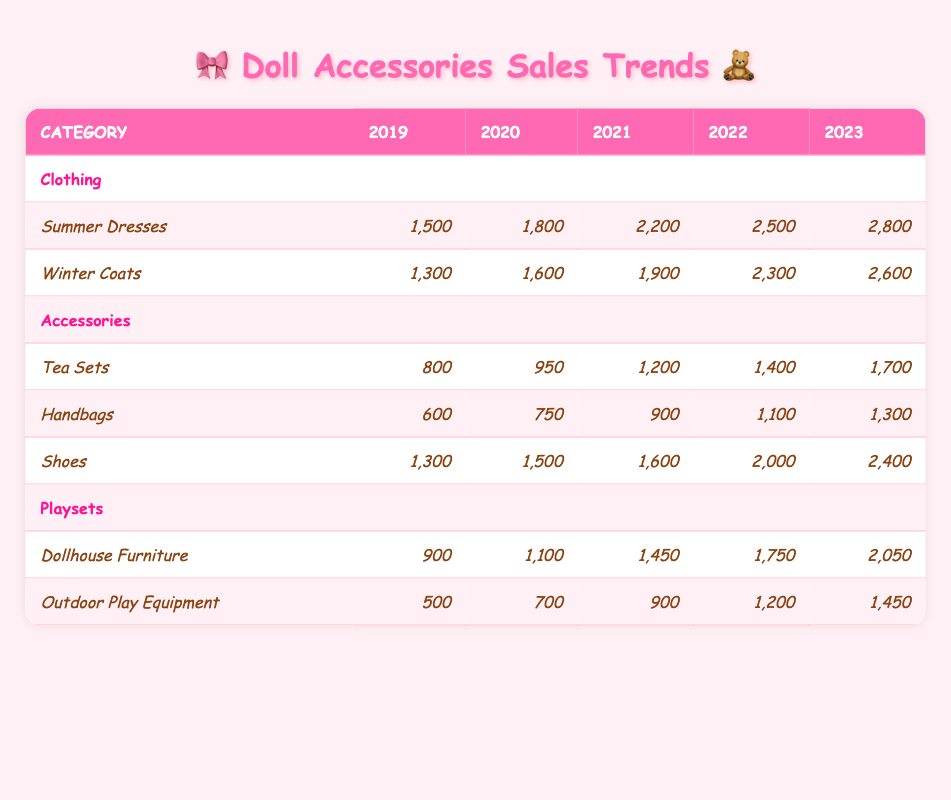What were the sales of Summer Dresses in 2021? According to the table, the sales of Summer Dresses in 2021 are listed as 2,200.
Answer: 2,200 Which category had the highest total sales in 2023? To find the highest total sales, we need to add the sales for each category in 2023: Clothing (2,800) + Accessories (1,700 + 1,300 + 2,400) + Playsets (2,050 + 1,450) = 2,800 + 5,400 + 3,500 = 11,700. Therefore, the category with the highest total is Clothing.
Answer: Clothing Did the sales of Tea Sets increase every year? The sales figures for Tea Sets are: 800 (2019), 950 (2020), 1200 (2021), 1400 (2022), and 1700 (2023). Since all values show an increase year over year, the answer is yes.
Answer: Yes What is the average sales of Shoes over the five years? To find the average sales of Shoes, we sum the sales from 2019 to 2023: 1,300 + 1,500 + 1,600 + 2,000 + 2,400 = 10,800. Then, we divide this sum by the five years: 10,800 / 5 = 2,160.
Answer: 2,160 Which had higher sales in 2022, Winter Coats or Dollhouse Furniture? The sales for Winter Coats in 2022 is 2,300 and for Dollhouse Furniture is 1,750. Since 2,300 is greater than 1,750, Winter Coats had higher sales in 2022.
Answer: Winter Coats How much did the sales of Handbags grow from 2019 to 2023? The sales of Handbags in 2019 were 600 and in 2023 it was 1,300. To find the growth, subtract the earlier value from the later value: 1,300 - 600 = 700. Thus, Handbags sales grew by 700 from 2019 to 2023.
Answer: 700 Which accessory category showed the least sales in 2020? In 2020, the sales for Handbags was 750, Tea Sets was 950, and Shoes was 1,500. Among these, Handbags had the least amount of sales in 2020.
Answer: Handbags Did Outdoor Play Equipment have more sales in 2023 compared to 2021? The sales for Outdoor Play Equipment were 900 in 2021 and increased to 1,450 in 2023. Since 1,450 is greater than 900, the answer is yes.
Answer: Yes 